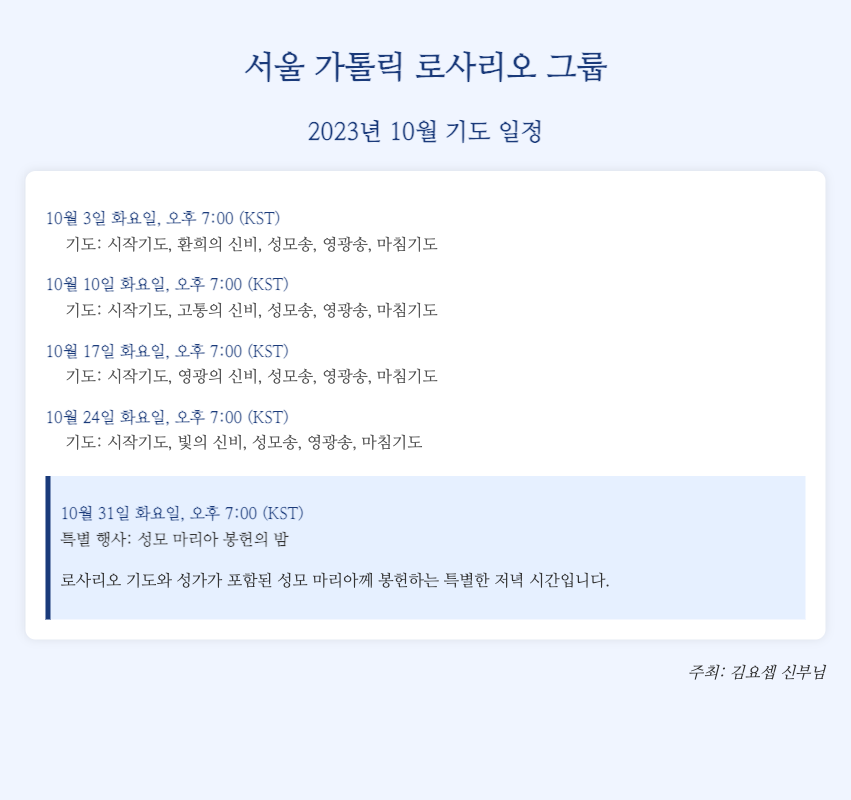What is the name of the group? The title of the document mentions the name of the group, which is "서울 가톨릭 로사리오 그룹".
Answer: 서울 가톨릭 로사리오 그룹 What is the date of the special event? The special event is noted prominently within the schedule as occurring on a specific date, which is "10월 31일".
Answer: 10월 31일 What time do the prayers start on October 10th? The schedule specifies the time for the prayers on October 10th as "오후 7:00 (KST)".
Answer: 오후 7:00 (KST) What kind of prayers are recited on October 17th? The document lists the type of prayers for October 17th, which include "시작기도, 영광의 신비, 성모송, 영광송, 마침기도".
Answer: 시작기도, 영광의 신비, 성모송, 영광송, 마침기도 Who is organizing the prayer events? The last part of the document states the name of the person organizing the events, which is "김요셉 신부님".
Answer: 김요셉 신부님 How many times will the Rosary be prayed in October? By counting the dates listed in the schedule, we can see that there are five prayer sessions scheduled for the month.
Answer: 5 